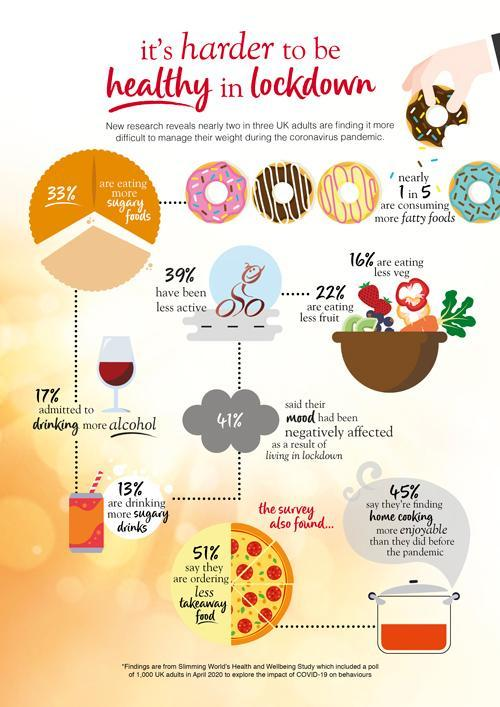What is the color of the text in the heading -red or black?
Answer the question with a short phrase. red What percent of people find home cooking not more enjoyable than that before the pandemic? 55% what percentage of people does not consuming more sugary foods in lockdown? 67% what percentage of people does not consuming more fatty foods in lockdown? 80% what percentage of people does not become less active in lockdown? 61% 